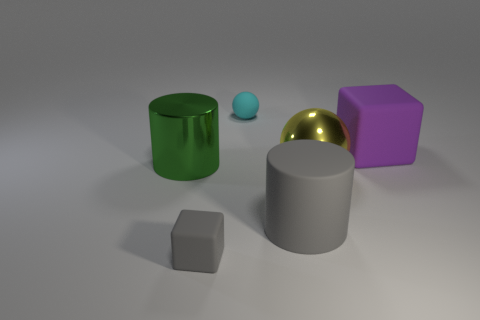What number of objects are either cylinders that are in front of the yellow metallic object or tiny objects that are behind the large metal cylinder?
Ensure brevity in your answer.  2. There is a rubber object that is left of the thing behind the matte cube that is behind the yellow metal sphere; what is its size?
Make the answer very short. Small. Are there the same number of cyan rubber things in front of the cyan rubber ball and brown matte cylinders?
Your response must be concise. Yes. There is a big purple thing; is it the same shape as the small matte thing that is in front of the big green object?
Your answer should be very brief. Yes. The gray thing that is the same shape as the purple thing is what size?
Your answer should be compact. Small. What number of other things are the same material as the green thing?
Ensure brevity in your answer.  1. What is the material of the tiny cyan object?
Provide a short and direct response. Rubber. Is the color of the matte block in front of the big purple thing the same as the cylinder that is to the left of the gray cube?
Provide a succinct answer. No. Is the number of things that are behind the big matte cube greater than the number of big cyan objects?
Keep it short and to the point. Yes. How many other objects are the same color as the matte cylinder?
Provide a succinct answer. 1. 